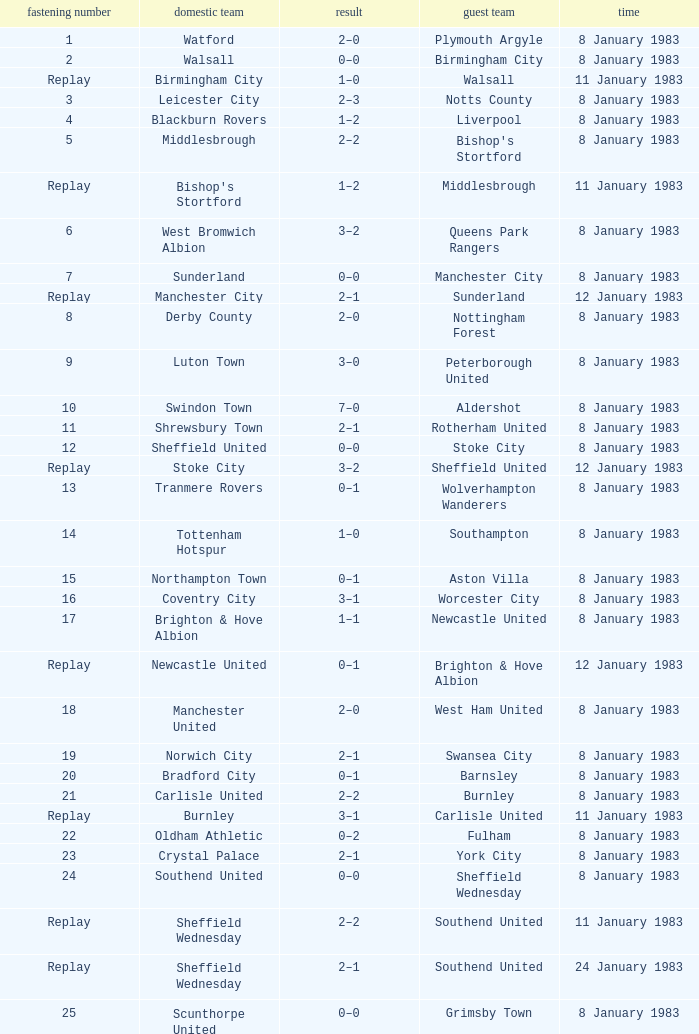In the tie where Southampton was the away team, who was the home team? Tottenham Hotspur. 